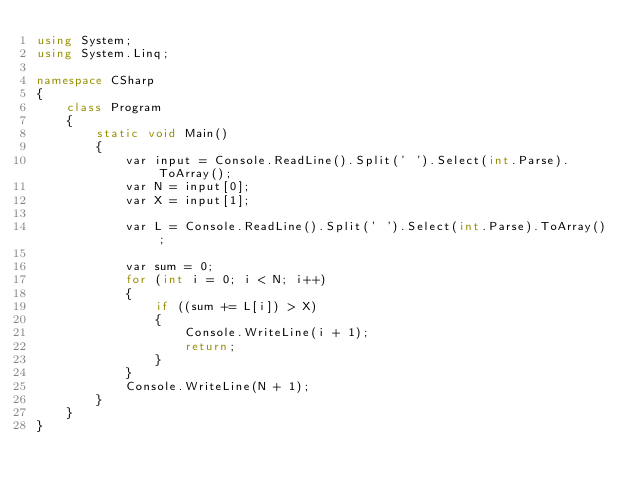Convert code to text. <code><loc_0><loc_0><loc_500><loc_500><_C#_>using System;
using System.Linq;

namespace CSharp
{
    class Program
    {
        static void Main()
        {
            var input = Console.ReadLine().Split(' ').Select(int.Parse).ToArray();
            var N = input[0];
            var X = input[1];

            var L = Console.ReadLine().Split(' ').Select(int.Parse).ToArray();

            var sum = 0;
            for (int i = 0; i < N; i++)
            {
                if ((sum += L[i]) > X)
                {
                    Console.WriteLine(i + 1);
                    return;
                }
            }
            Console.WriteLine(N + 1);
        }
    }
}</code> 